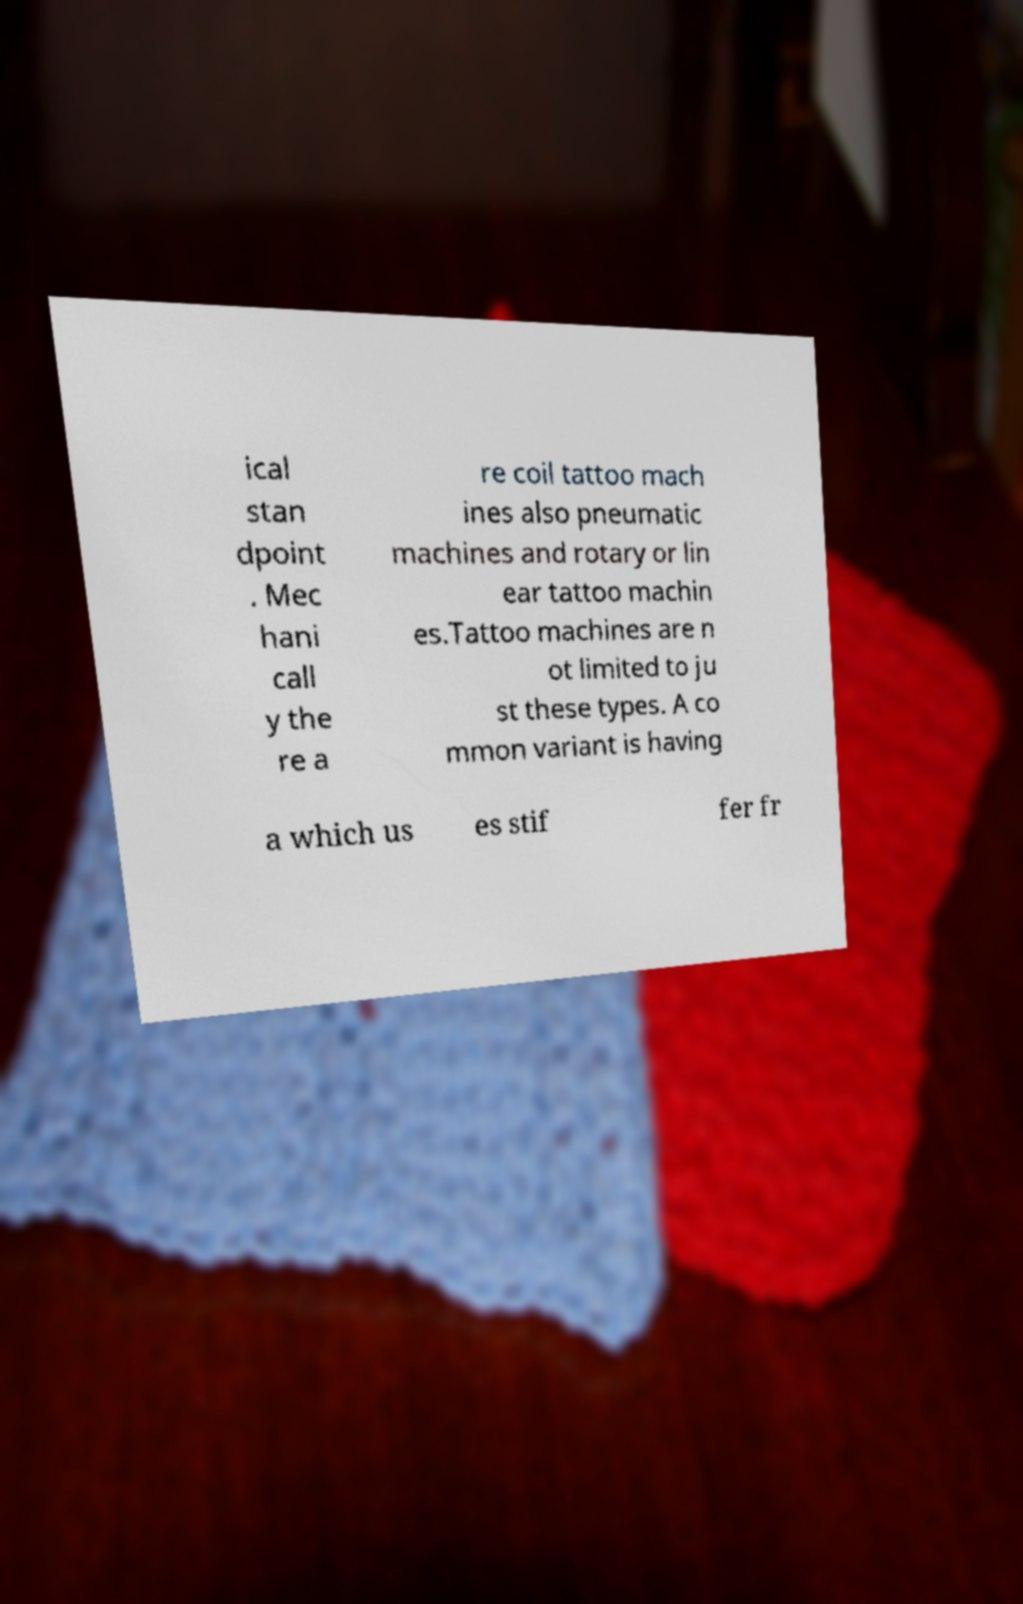Could you assist in decoding the text presented in this image and type it out clearly? ical stan dpoint . Mec hani call y the re a re coil tattoo mach ines also pneumatic machines and rotary or lin ear tattoo machin es.Tattoo machines are n ot limited to ju st these types. A co mmon variant is having a which us es stif fer fr 